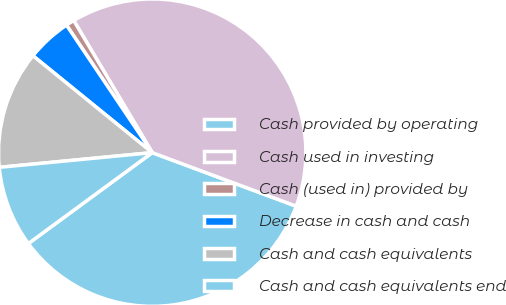<chart> <loc_0><loc_0><loc_500><loc_500><pie_chart><fcel>Cash provided by operating<fcel>Cash used in investing<fcel>Cash (used in) provided by<fcel>Decrease in cash and cash<fcel>Cash and cash equivalents<fcel>Cash and cash equivalents end<nl><fcel>34.25%<fcel>39.19%<fcel>0.89%<fcel>4.72%<fcel>12.38%<fcel>8.55%<nl></chart> 